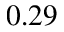Convert formula to latex. <formula><loc_0><loc_0><loc_500><loc_500>0 . 2 9</formula> 